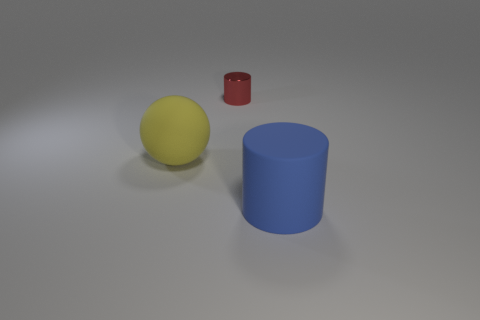Is there anything else that has the same size as the shiny thing?
Give a very brief answer. No. What number of big objects are there?
Your response must be concise. 2. What is the color of the cylinder that is in front of the small red cylinder?
Provide a short and direct response. Blue. There is a cylinder that is on the left side of the large rubber object that is right of the yellow matte object; what color is it?
Offer a terse response. Red. What is the color of the cylinder that is the same size as the ball?
Your answer should be very brief. Blue. How many objects are in front of the red object and on the right side of the yellow ball?
Make the answer very short. 1. There is a thing that is in front of the tiny red cylinder and to the right of the yellow matte ball; what is its material?
Provide a short and direct response. Rubber. Is the number of large matte spheres in front of the metal thing less than the number of large blue matte cylinders left of the big blue object?
Offer a terse response. No. What is the size of the cylinder that is made of the same material as the big ball?
Offer a very short reply. Large. Is there anything else that has the same color as the small thing?
Your answer should be compact. No. 